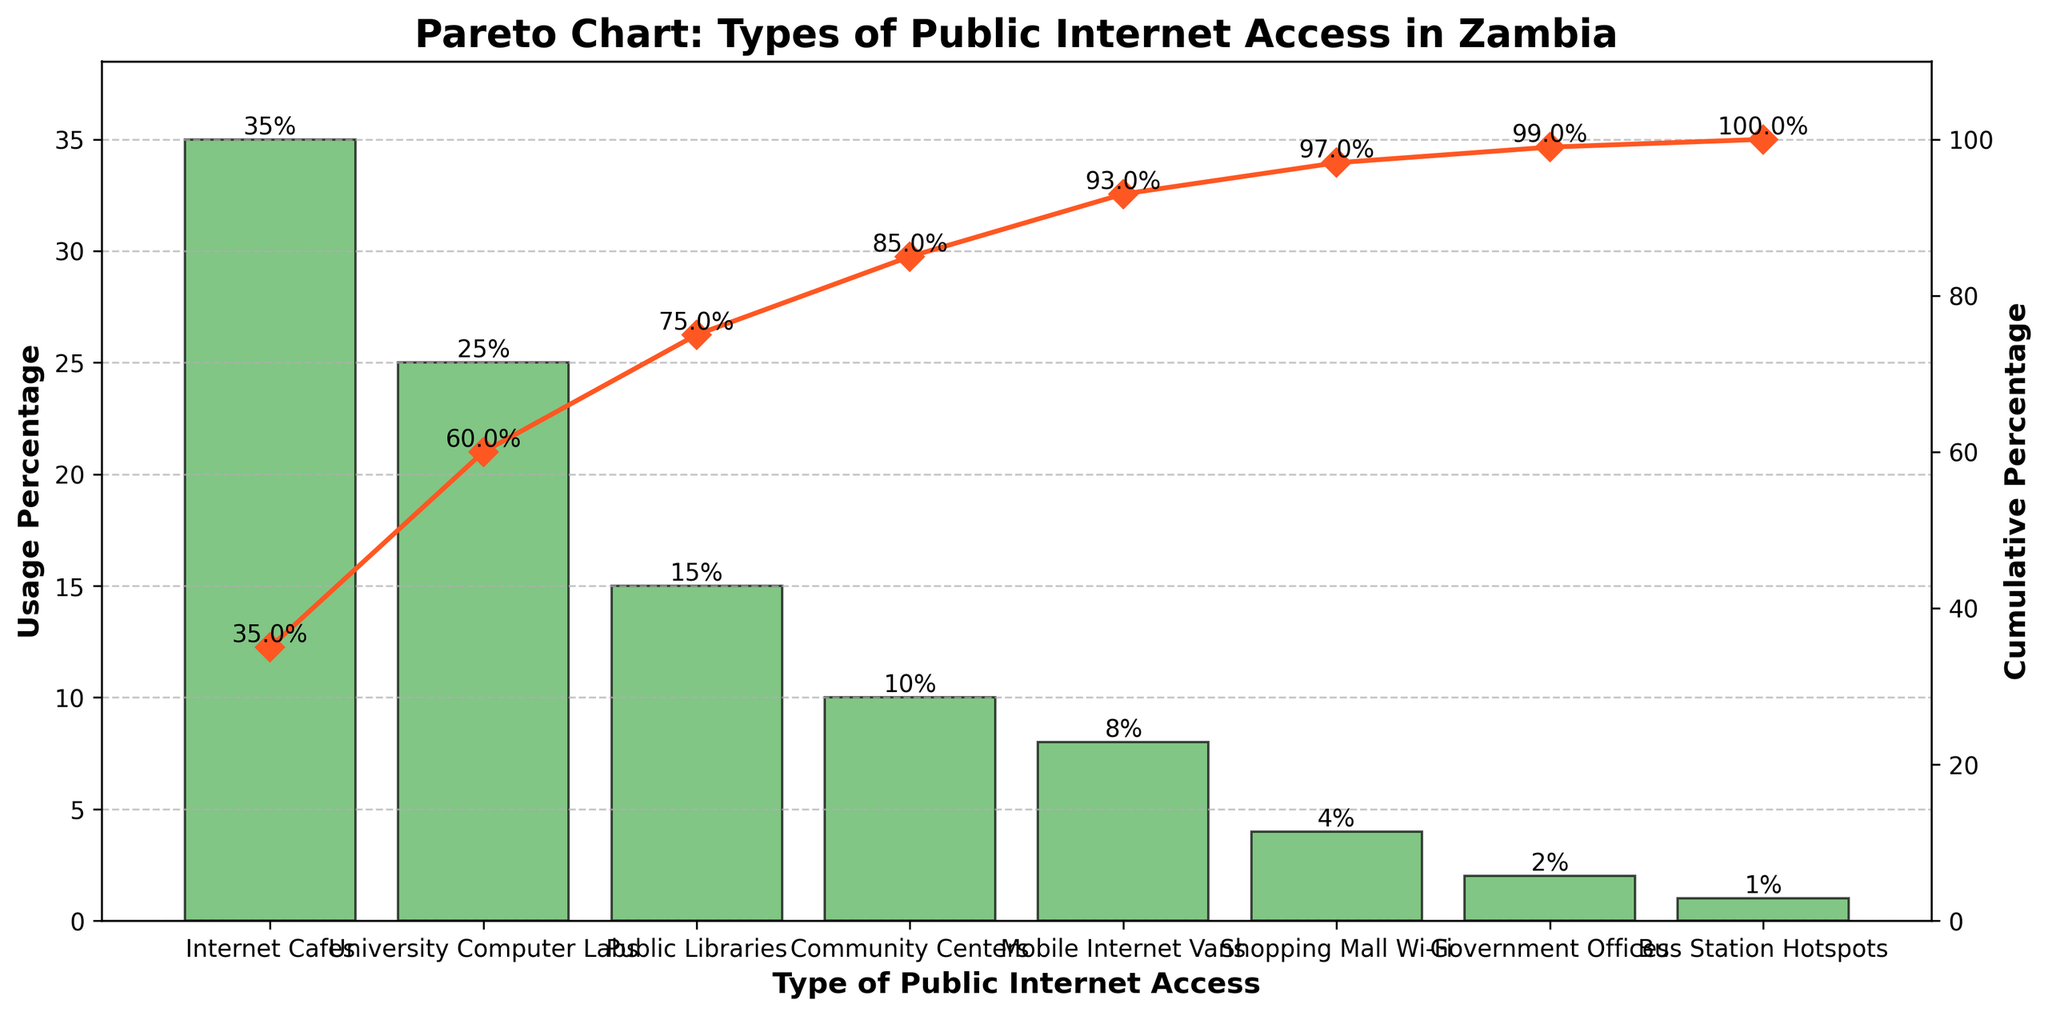What is the title of the figure? The title is typically found at the top of the chart and provides a brief description of what the figure represents. In this case, it denotes the chart's focus on public internet access types in Zambia.
Answer: Pareto Chart: Types of Public Internet Access in Zambia Which type of public internet access has the highest usage percentage? By examining the bar heights, the one with the highest bar represents the type with the highest usage percentage.
Answer: Internet Cafes What is the cumulative percentage for Internet Cafes and University Computer Labs combined? Add the usage percentage of Internet Cafes (35%) and University Computer Labs (25%) to get the cumulative percentage.
Answer: 60% How does the usage of Public Libraries compare to that of Community Centers? Look at the height of the bars for Public Libraries and Community Centers. The bar for Public Libraries is higher than that for Community Centers.
Answer: Public Libraries have a higher usage Which type of public internet access shows a cumulative percentage closest to 50%? Observe the line chart and find the data point where the cumulative percentage first exceeds 50%.
Answer: University Computer Labs How many types of public internet access have usage percentages less than 5%? Identify the bars that are below the 5% mark on the y-axis.
Answer: Three types (Shopping Mall Wi-Fi, Government Offices, Bus Station Hotspots) What is the total percentage covered by the top three types of public internet access? Sum the usage percentages of Internet Cafes, University Computer Labs, and Public Libraries (35% + 25% + 15%).
Answer: 75% Which type of public internet access has the lowest usage percentage? The shortest bar signifies the least used type.
Answer: Bus Station Hotspots What percentage drop is there from Internet Cafes to Public Libraries? Subtract the usage percentage of Public Libraries (15%) from that of Internet Cafes (35%).
Answer: 20% What is the cumulative usage percentage for the top four types of public internet access? Sum the usage percentages of Internet Cafes, University Computer Labs, Public Libraries, and Community Centers (35% + 25% + 15% + 10%).
Answer: 85% 